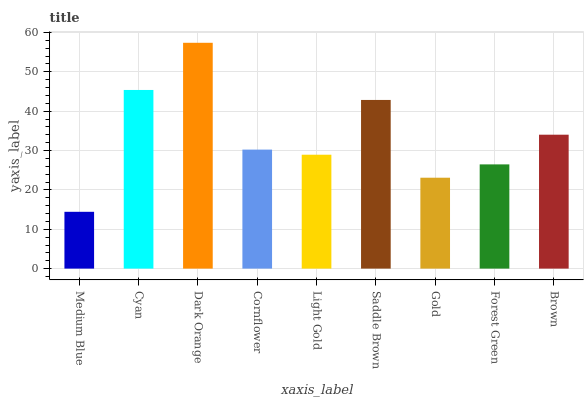Is Medium Blue the minimum?
Answer yes or no. Yes. Is Dark Orange the maximum?
Answer yes or no. Yes. Is Cyan the minimum?
Answer yes or no. No. Is Cyan the maximum?
Answer yes or no. No. Is Cyan greater than Medium Blue?
Answer yes or no. Yes. Is Medium Blue less than Cyan?
Answer yes or no. Yes. Is Medium Blue greater than Cyan?
Answer yes or no. No. Is Cyan less than Medium Blue?
Answer yes or no. No. Is Cornflower the high median?
Answer yes or no. Yes. Is Cornflower the low median?
Answer yes or no. Yes. Is Forest Green the high median?
Answer yes or no. No. Is Saddle Brown the low median?
Answer yes or no. No. 